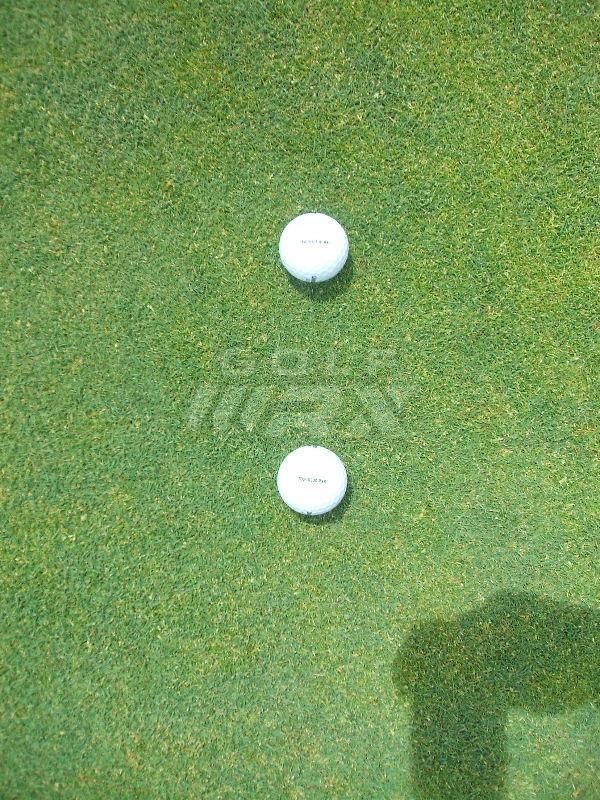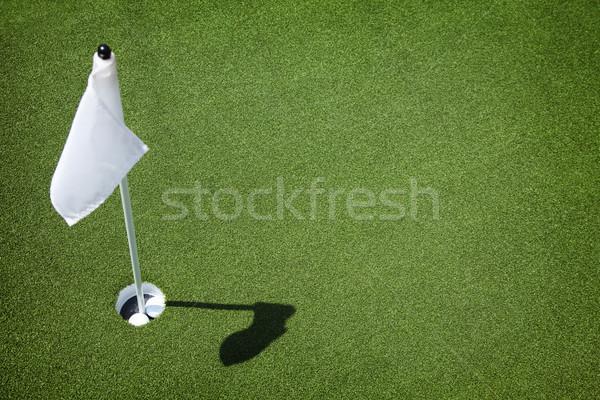The first image is the image on the left, the second image is the image on the right. Examine the images to the left and right. Is the description "A golf ball is within a ball's-width of a hole with no flag in it." accurate? Answer yes or no. No. The first image is the image on the left, the second image is the image on the right. Examine the images to the left and right. Is the description "There is at least two golf balls in the left image." accurate? Answer yes or no. Yes. 